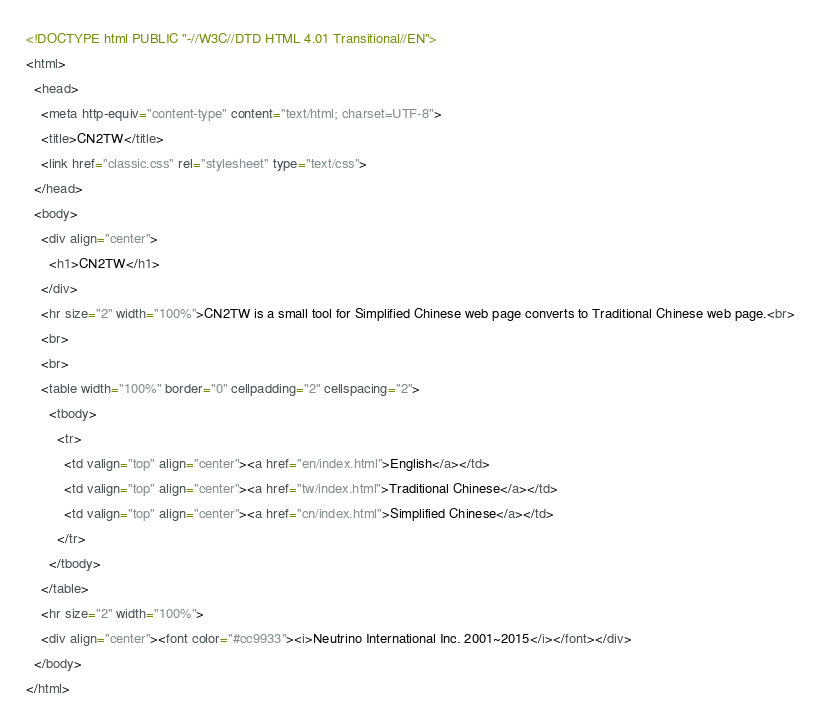Convert code to text. <code><loc_0><loc_0><loc_500><loc_500><_HTML_><!DOCTYPE html PUBLIC "-//W3C//DTD HTML 4.01 Transitional//EN">
<html>
  <head>
    <meta http-equiv="content-type" content="text/html; charset=UTF-8">
    <title>CN2TW</title>
    <link href="classic.css" rel="stylesheet" type="text/css">
  </head>
  <body>
    <div align="center">
      <h1>CN2TW</h1>
    </div>
    <hr size="2" width="100%">CN2TW is a small tool for Simplified Chinese web page converts to Traditional Chinese web page.<br>
    <br>
    <br>
    <table width="100%" border="0" cellpadding="2" cellspacing="2">
      <tbody>
        <tr>
          <td valign="top" align="center"><a href="en/index.html">English</a></td>
          <td valign="top" align="center"><a href="tw/index.html">Traditional Chinese</a></td>
          <td valign="top" align="center"><a href="cn/index.html">Simplified Chinese</a></td>
        </tr>
      </tbody>
    </table>
    <hr size="2" width="100%">
    <div align="center"><font color="#cc9933"><i>Neutrino International Inc. 2001~2015</i></font></div>
  </body>
</html>
</code> 